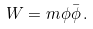Convert formula to latex. <formula><loc_0><loc_0><loc_500><loc_500>W = m \phi \bar { \phi } \, .</formula> 